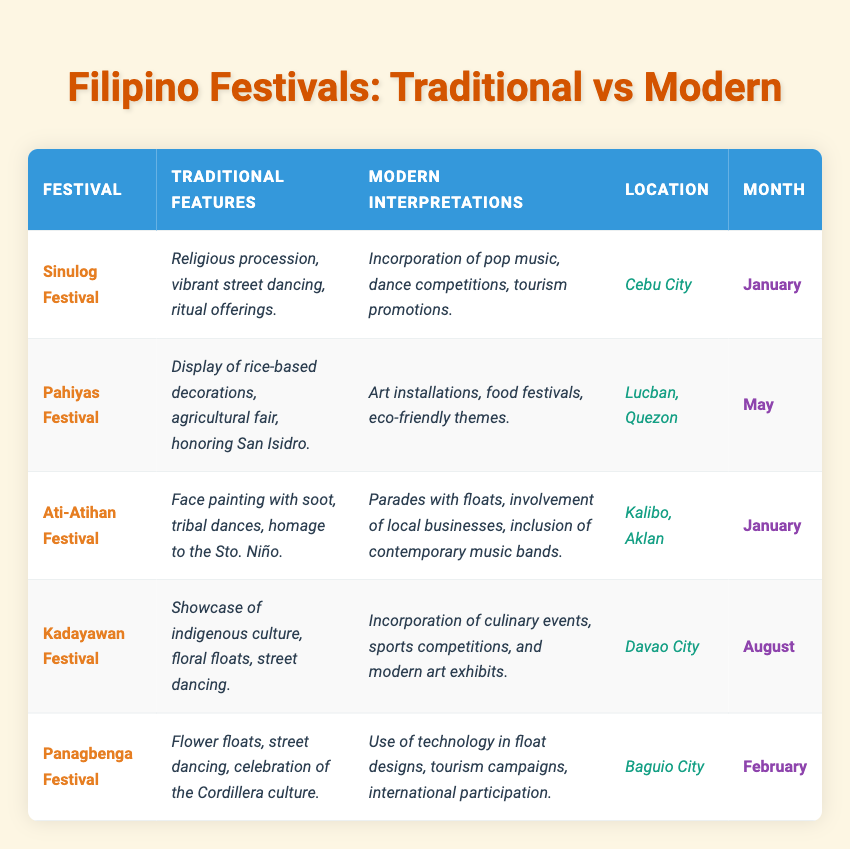What month is the Sinulog Festival celebrated? The table lists the month of the Sinulog Festival under the "Month" column, which shows January.
Answer: January Which festival features rice-based decorations? The Pahiyas Festival has a traditional feature of displaying rice-based decorations, as stated in the "Traditional Features" column.
Answer: Pahiyas Festival How many festivals are held in January? There are two festivals listed in the table that are celebrated in January: Sinulog Festival and Ati-Atihan Festival.
Answer: 2 Is Kadayawan Festival celebrated in the same month as Panagbenga Festival? Looking at the "Month" column, Kadayawan Festival is in August and Panagbenga Festival is in February, so they are not celebrated in the same month.
Answer: No Which festival includes modern art exhibits among its modern interpretations? The Kadayawan Festival is noted for incorporating modern art exhibits in its modern interpretations section of the table.
Answer: Kadayawan Festival What is a common theme in the modern interpretations of the Pahiyas Festival? The Pahiyas Festival modern interpretations emphasize eco-friendly themes, as stated in the table.
Answer: Eco-friendly themes What are the traditional features of the Ati-Atihan Festival? The table indicates that traditional features of the Ati-Atihan Festival include face painting with soot, tribal dances, and homage to Sto. Niño.
Answer: Face painting with soot, tribal dances, homage to Sto. Niño How does the modern interpretation of Sinulog Festival compare with its traditional features? The Sinulog Festival’s modern interpretation incorporates pop music and dance competitions, while its traditional features focus on religious processions and ritual offerings, indicating a shift towards entertainment and tourism.
Answer: Shift towards entertainment and tourism Which festival is associated with the month of February and includes flower floats? The Panagbenga Festival is associated with February and features flower floats as part of its traditional characteristics.
Answer: Panagbenga Festival What location is associated with the Kadayawan Festival? The table states that the Kadayawan Festival is located in Davao City.
Answer: Davao City Are there any festivals that involve agricultural fairs in their traditional features? Yes, the Pahiyas Festival mentions agricultural fairs among its traditional features in the table.
Answer: Yes 